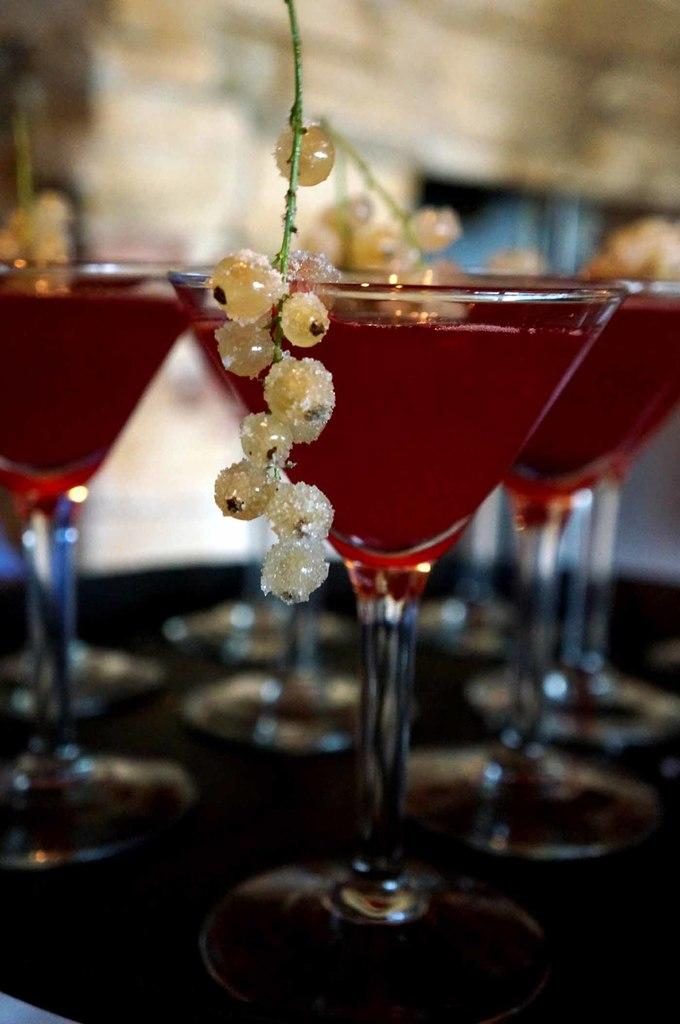What is in the glasses that are visible in the image? There are glasses with juice in the image. What other items can be seen in the image besides the glasses with juice? There are fruits in the image. Where are the glasses with juice and fruits placed in the image? The glasses with juice and fruits are placed on a table. What type of can is visible in the image? There is no can present in the image; it features glasses with juice and fruits. What shape is the circle that is visible in the image? There is no circle present in the image. 